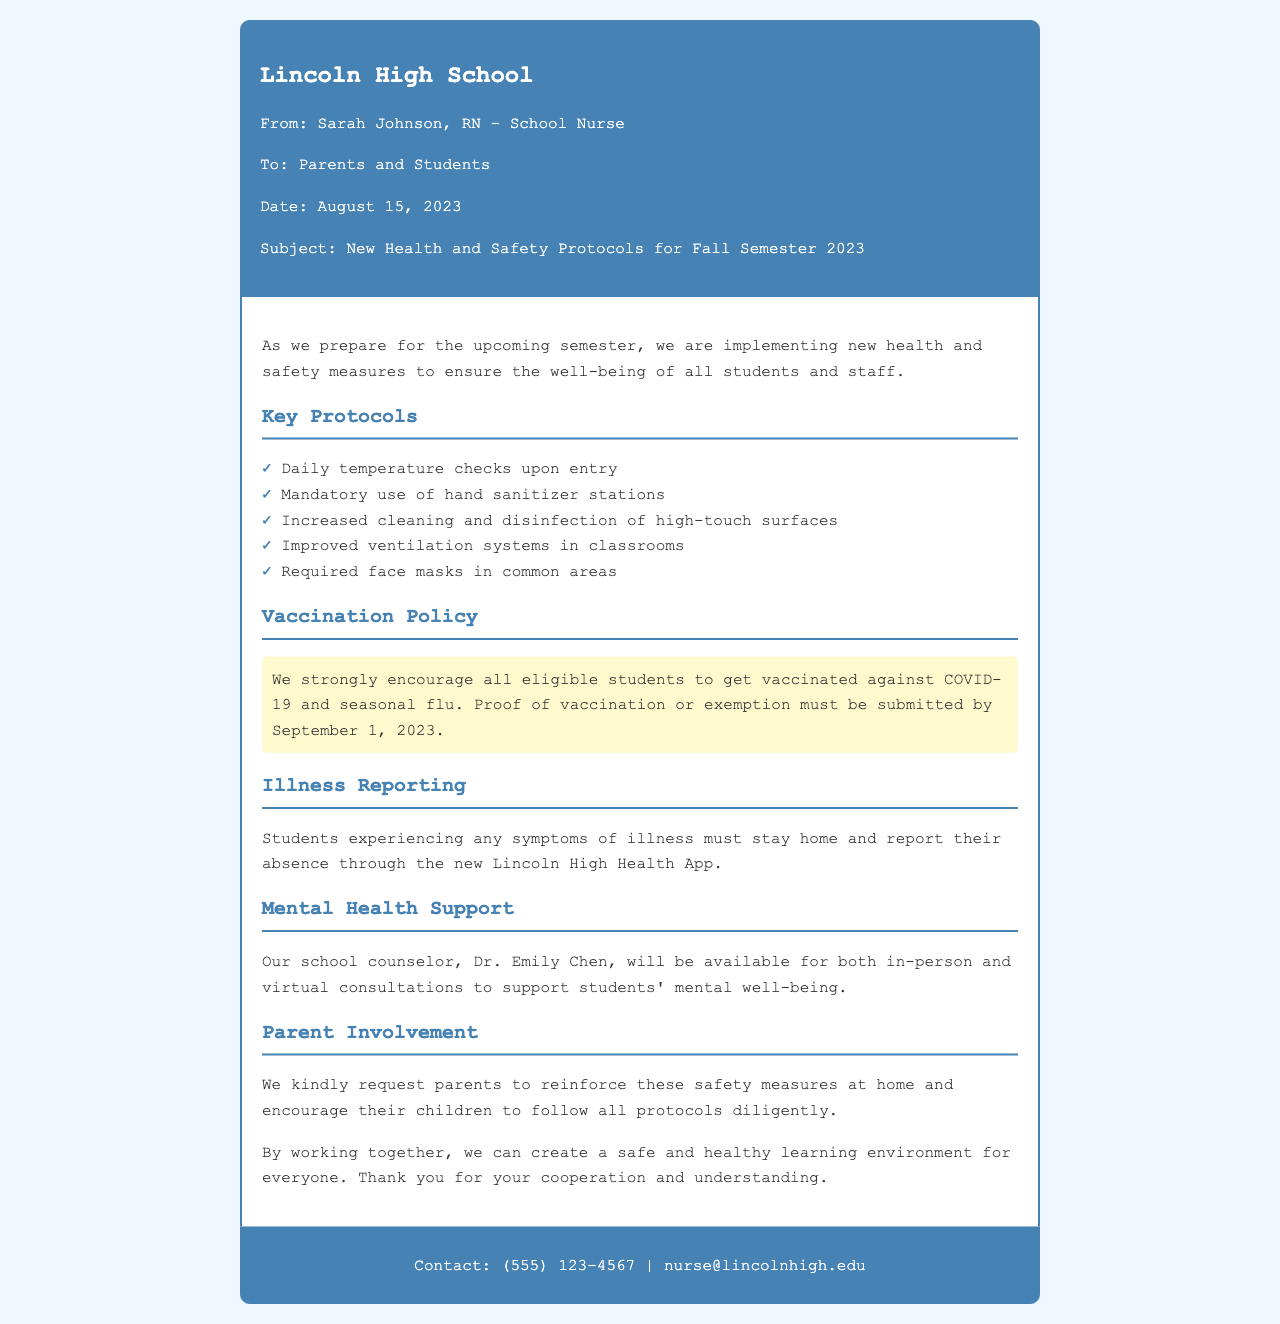What is the name of the school? The name of the school is mentioned at the top of the fax.
Answer: Lincoln High School Who is the sender of the fax? The sender's name and title is provided in the header of the fax.
Answer: Sarah Johnson, RN What is the date of the fax? The date can be found in the header section of the fax document.
Answer: August 15, 2023 What is required for students experiencing symptoms of illness? This information is provided under the Illness Reporting section.
Answer: Stay home and report absence What is strongly encouraged for eligible students? This is detailed under the Vaccination Policy section of the fax.
Answer: Get vaccinated What should parents encourage their children to do? This request is made in the Parent Involvement section of the fax.
Answer: Follow all protocols diligently How many key protocols are listed? This can be determined by counting the items in the Key Protocols section.
Answer: Five Who can students contact for mental health support? The mental health support section names the counselor available for assistance.
Answer: Dr. Emily Chen What is the deadline for submitting proof of vaccination or exemption? This information is mentioned in the Vaccination Policy section.
Answer: September 1, 2023 